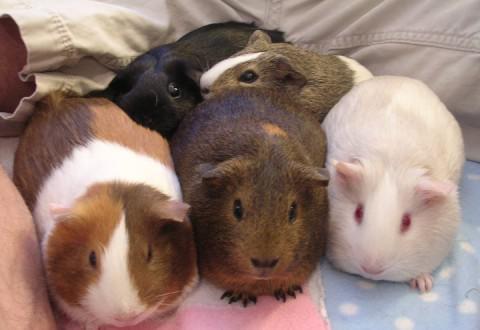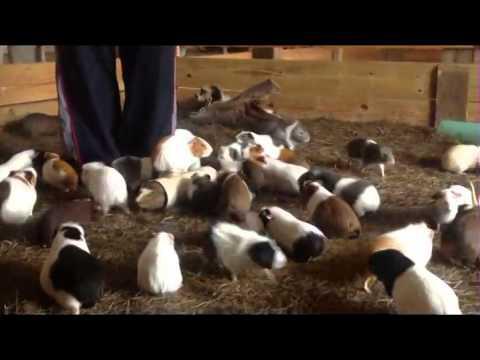The first image is the image on the left, the second image is the image on the right. Assess this claim about the two images: "Neither individual image includes more than seven guinea pigs.". Correct or not? Answer yes or no. No. 